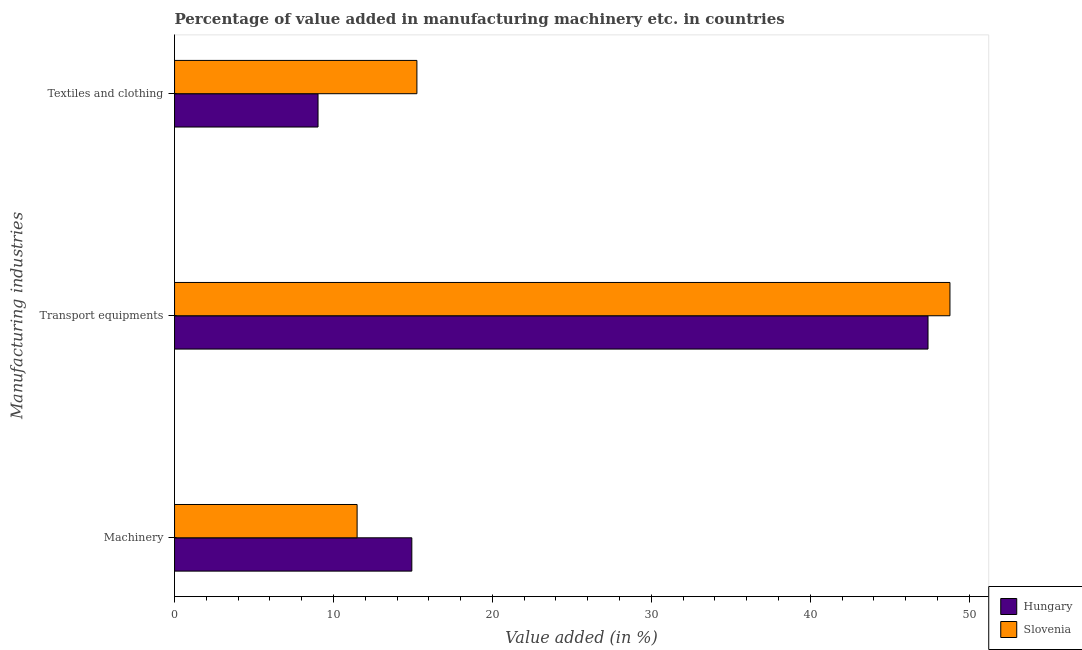How many different coloured bars are there?
Give a very brief answer. 2. How many groups of bars are there?
Provide a succinct answer. 3. Are the number of bars on each tick of the Y-axis equal?
Your answer should be compact. Yes. How many bars are there on the 3rd tick from the top?
Your response must be concise. 2. What is the label of the 3rd group of bars from the top?
Offer a very short reply. Machinery. What is the value added in manufacturing textile and clothing in Slovenia?
Offer a terse response. 15.25. Across all countries, what is the maximum value added in manufacturing textile and clothing?
Your response must be concise. 15.25. Across all countries, what is the minimum value added in manufacturing transport equipments?
Provide a short and direct response. 47.41. In which country was the value added in manufacturing transport equipments maximum?
Offer a terse response. Slovenia. In which country was the value added in manufacturing textile and clothing minimum?
Offer a terse response. Hungary. What is the total value added in manufacturing machinery in the graph?
Offer a terse response. 26.42. What is the difference between the value added in manufacturing transport equipments in Hungary and that in Slovenia?
Keep it short and to the point. -1.38. What is the difference between the value added in manufacturing machinery in Slovenia and the value added in manufacturing textile and clothing in Hungary?
Make the answer very short. 2.46. What is the average value added in manufacturing textile and clothing per country?
Your response must be concise. 12.14. What is the difference between the value added in manufacturing textile and clothing and value added in manufacturing machinery in Hungary?
Give a very brief answer. -5.9. In how many countries, is the value added in manufacturing transport equipments greater than 20 %?
Your answer should be very brief. 2. What is the ratio of the value added in manufacturing machinery in Hungary to that in Slovenia?
Provide a short and direct response. 1.3. Is the value added in manufacturing textile and clothing in Hungary less than that in Slovenia?
Make the answer very short. Yes. Is the difference between the value added in manufacturing textile and clothing in Slovenia and Hungary greater than the difference between the value added in manufacturing transport equipments in Slovenia and Hungary?
Make the answer very short. Yes. What is the difference between the highest and the second highest value added in manufacturing machinery?
Make the answer very short. 3.44. What is the difference between the highest and the lowest value added in manufacturing textile and clothing?
Ensure brevity in your answer.  6.22. In how many countries, is the value added in manufacturing textile and clothing greater than the average value added in manufacturing textile and clothing taken over all countries?
Offer a very short reply. 1. Is the sum of the value added in manufacturing textile and clothing in Slovenia and Hungary greater than the maximum value added in manufacturing machinery across all countries?
Provide a short and direct response. Yes. What does the 2nd bar from the top in Transport equipments represents?
Provide a short and direct response. Hungary. What does the 2nd bar from the bottom in Textiles and clothing represents?
Your response must be concise. Slovenia. Is it the case that in every country, the sum of the value added in manufacturing machinery and value added in manufacturing transport equipments is greater than the value added in manufacturing textile and clothing?
Provide a succinct answer. Yes. How many bars are there?
Provide a short and direct response. 6. How many countries are there in the graph?
Your answer should be very brief. 2. What is the difference between two consecutive major ticks on the X-axis?
Your response must be concise. 10. Are the values on the major ticks of X-axis written in scientific E-notation?
Offer a very short reply. No. Does the graph contain grids?
Ensure brevity in your answer.  No. Where does the legend appear in the graph?
Make the answer very short. Bottom right. How many legend labels are there?
Offer a very short reply. 2. How are the legend labels stacked?
Offer a very short reply. Vertical. What is the title of the graph?
Offer a terse response. Percentage of value added in manufacturing machinery etc. in countries. Does "Sudan" appear as one of the legend labels in the graph?
Offer a very short reply. No. What is the label or title of the X-axis?
Offer a terse response. Value added (in %). What is the label or title of the Y-axis?
Ensure brevity in your answer.  Manufacturing industries. What is the Value added (in %) of Hungary in Machinery?
Your answer should be compact. 14.93. What is the Value added (in %) of Slovenia in Machinery?
Ensure brevity in your answer.  11.49. What is the Value added (in %) of Hungary in Transport equipments?
Offer a terse response. 47.41. What is the Value added (in %) in Slovenia in Transport equipments?
Your response must be concise. 48.79. What is the Value added (in %) of Hungary in Textiles and clothing?
Provide a short and direct response. 9.03. What is the Value added (in %) of Slovenia in Textiles and clothing?
Offer a very short reply. 15.25. Across all Manufacturing industries, what is the maximum Value added (in %) in Hungary?
Make the answer very short. 47.41. Across all Manufacturing industries, what is the maximum Value added (in %) of Slovenia?
Offer a very short reply. 48.79. Across all Manufacturing industries, what is the minimum Value added (in %) in Hungary?
Provide a succinct answer. 9.03. Across all Manufacturing industries, what is the minimum Value added (in %) of Slovenia?
Make the answer very short. 11.49. What is the total Value added (in %) of Hungary in the graph?
Keep it short and to the point. 71.37. What is the total Value added (in %) of Slovenia in the graph?
Provide a short and direct response. 75.52. What is the difference between the Value added (in %) in Hungary in Machinery and that in Transport equipments?
Provide a succinct answer. -32.48. What is the difference between the Value added (in %) of Slovenia in Machinery and that in Transport equipments?
Ensure brevity in your answer.  -37.3. What is the difference between the Value added (in %) of Hungary in Machinery and that in Textiles and clothing?
Give a very brief answer. 5.9. What is the difference between the Value added (in %) of Slovenia in Machinery and that in Textiles and clothing?
Your answer should be very brief. -3.76. What is the difference between the Value added (in %) in Hungary in Transport equipments and that in Textiles and clothing?
Provide a short and direct response. 38.38. What is the difference between the Value added (in %) of Slovenia in Transport equipments and that in Textiles and clothing?
Offer a very short reply. 33.54. What is the difference between the Value added (in %) in Hungary in Machinery and the Value added (in %) in Slovenia in Transport equipments?
Provide a succinct answer. -33.86. What is the difference between the Value added (in %) of Hungary in Machinery and the Value added (in %) of Slovenia in Textiles and clothing?
Your answer should be very brief. -0.32. What is the difference between the Value added (in %) in Hungary in Transport equipments and the Value added (in %) in Slovenia in Textiles and clothing?
Offer a terse response. 32.16. What is the average Value added (in %) in Hungary per Manufacturing industries?
Offer a very short reply. 23.79. What is the average Value added (in %) of Slovenia per Manufacturing industries?
Provide a short and direct response. 25.17. What is the difference between the Value added (in %) in Hungary and Value added (in %) in Slovenia in Machinery?
Your answer should be very brief. 3.44. What is the difference between the Value added (in %) in Hungary and Value added (in %) in Slovenia in Transport equipments?
Your response must be concise. -1.38. What is the difference between the Value added (in %) in Hungary and Value added (in %) in Slovenia in Textiles and clothing?
Offer a terse response. -6.22. What is the ratio of the Value added (in %) in Hungary in Machinery to that in Transport equipments?
Your answer should be very brief. 0.31. What is the ratio of the Value added (in %) of Slovenia in Machinery to that in Transport equipments?
Ensure brevity in your answer.  0.24. What is the ratio of the Value added (in %) in Hungary in Machinery to that in Textiles and clothing?
Offer a terse response. 1.65. What is the ratio of the Value added (in %) of Slovenia in Machinery to that in Textiles and clothing?
Your answer should be very brief. 0.75. What is the ratio of the Value added (in %) in Hungary in Transport equipments to that in Textiles and clothing?
Your answer should be compact. 5.25. What is the ratio of the Value added (in %) in Slovenia in Transport equipments to that in Textiles and clothing?
Make the answer very short. 3.2. What is the difference between the highest and the second highest Value added (in %) in Hungary?
Your answer should be very brief. 32.48. What is the difference between the highest and the second highest Value added (in %) of Slovenia?
Keep it short and to the point. 33.54. What is the difference between the highest and the lowest Value added (in %) of Hungary?
Offer a terse response. 38.38. What is the difference between the highest and the lowest Value added (in %) in Slovenia?
Offer a terse response. 37.3. 